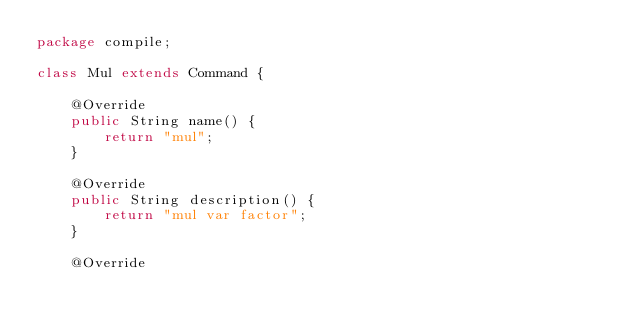Convert code to text. <code><loc_0><loc_0><loc_500><loc_500><_Java_>package compile;

class Mul extends Command {

	@Override
	public String name() {
		return "mul";
	}
	
	@Override
	public String description() {
		return "mul var factor";
	}
	
	@Override</code> 